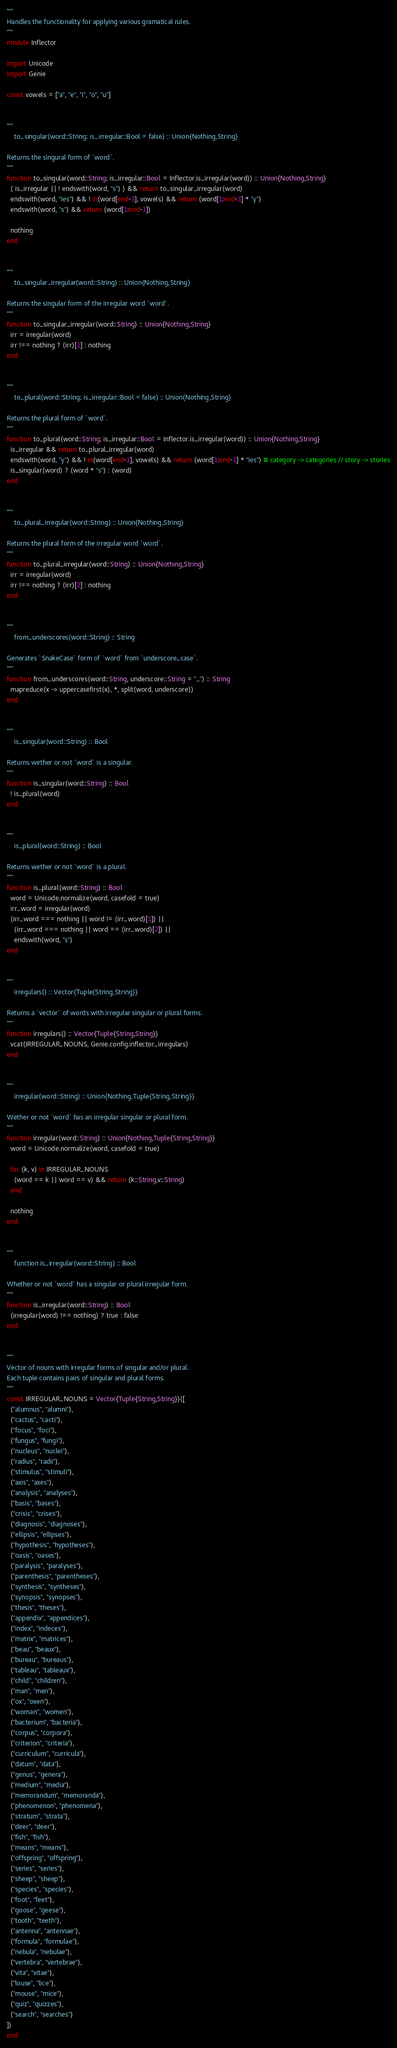<code> <loc_0><loc_0><loc_500><loc_500><_Julia_>"""
Handles the functionality for applying various gramatical rules.
"""
module Inflector

import Unicode
import Genie

const vowels = ["a", "e", "i", "o", "u"]


"""
    to_singular(word::String; is_irregular::Bool = false) :: Union{Nothing,String}

Returns the singural form of `word`.
"""
function to_singular(word::String; is_irregular::Bool = Inflector.is_irregular(word)) :: Union{Nothing,String}
  ( is_irregular || ! endswith(word, "s") ) && return to_singular_irregular(word)
  endswith(word, "ies") && ! in(word[end-3], vowels) && return (word[1:end-3] * "y")
  endswith(word, "s") && return (word[1:end-1])

  nothing
end


"""
    to_singular_irregular(word::String) :: Union{Nothing,String}

Returns the singular form of the irregular word `word`.
"""
function to_singular_irregular(word::String) :: Union{Nothing,String}
  irr = irregular(word)
  irr !== nothing ? (irr)[1] : nothing
end


"""
    to_plural(word::String; is_irregular::Bool = false) :: Union{Nothing,String}

Returns the plural form of `word`.
"""
function to_plural(word::String; is_irregular::Bool = Inflector.is_irregular(word)) :: Union{Nothing,String}
  is_irregular && return to_plural_irregular(word)
  endswith(word, "y") && ! in(word[end-1], vowels) && return (word[1:end-1] * "ies") # category -> categories // story -> stories
  is_singular(word) ? (word * "s") : (word)
end


"""
    to_plural_irregular(word::String) :: Union{Nothing,String}

Returns the plural form of the irregular word `word`.
"""
function to_plural_irregular(word::String) :: Union{Nothing,String}
  irr = irregular(word)
  irr !== nothing ? (irr)[2] : nothing
end


"""
    from_underscores(word::String) :: String

Generates `SnakeCase` form of `word` from `underscore_case`.
"""
function from_underscores(word::String, underscore::String = "_") :: String
  mapreduce(x -> uppercasefirst(x), *, split(word, underscore))
end


"""
    is_singular(word::String) :: Bool

Returns wether or not `word` is a singular.
"""
function is_singular(word::String) :: Bool
  ! is_plural(word)
end


"""
    is_plural(word::String) :: Bool

Returns wether or not `word` is a plural.
"""
function is_plural(word::String) :: Bool
  word = Unicode.normalize(word, casefold = true)
  irr_word = irregular(word)
  (irr_word === nothing || word != (irr_word)[1]) ||
    (irr_word === nothing || word == (irr_word)[2]) ||
    endswith(word, "s")
end


"""
    irregulars() :: Vector{Tuple{String,String}}

Returns a `vector` of words with irregular singular or plural forms.
"""
function irregulars() :: Vector{Tuple{String,String}}
  vcat(IRREGULAR_NOUNS, Genie.config.inflector_irregulars)
end


"""
    irregular(word::String) :: Union{Nothing,Tuple{String,String}}

Wether or not `word` has an irregular singular or plural form.
"""
function irregular(word::String) :: Union{Nothing,Tuple{String,String}}
  word = Unicode.normalize(word, casefold = true)

  for (k, v) in IRREGULAR_NOUNS
    (word == k || word == v) && return (k::String,v::String)
  end

  nothing
end


"""
    function is_irregular(word::String) :: Bool

Whether or not `word` has a singular or plural irregular form.
"""
function is_irregular(word::String) :: Bool
  (irregular(word) !== nothing) ? true : false
end


"""
Vector of nouns with irregular forms of singular and/or plural.
Each tuple contains pairs of singular and plural forms.
"""
const IRREGULAR_NOUNS = Vector{Tuple{String,String}}([
  ("alumnus", "alumni"),
  ("cactus", "cacti"),
  ("focus", "foci"),
  ("fungus", "fungi"),
  ("nucleus", "nuclei"),
  ("radius", "radii"),
  ("stimulus", "stimuli"),
  ("axis", "axes"),
  ("analysis", "analyses"),
  ("basis", "bases"),
  ("crisis", "crises"),
  ("diagnosis", "diagnoses"),
  ("ellipsis", "ellipses"),
  ("hypothesis", "hypotheses"),
  ("oasis", "oases"),
  ("paralysis", "paralyses"),
  ("parenthesis", "parentheses"),
  ("synthesis", "syntheses"),
  ("synopsis", "synopses"),
  ("thesis", "theses"),
  ("appendix", "appendices"),
  ("index", "indeces"),
  ("matrix", "matrices"),
  ("beau", "beaux"),
  ("bureau", "bureaus"),
  ("tableau", "tableaux"),
  ("child", "children"),
  ("man", "men"),
  ("ox", "oxen"),
  ("woman", "women"),
  ("bacterium", "bacteria"),
  ("corpus", "corpora"),
  ("criterion", "criteria"),
  ("curriculum", "curricula"),
  ("datum", "data"),
  ("genus", "genera"),
  ("medium", "media"),
  ("memorandum", "memoranda"),
  ("phenomenon", "phenomena"),
  ("stratum", "strata"),
  ("deer", "deer"),
  ("fish", "fish"),
  ("means", "means"),
  ("offspring", "offspring"),
  ("series", "series"),
  ("sheep", "sheep"),
  ("species", "species"),
  ("foot", "feet"),
  ("goose", "geese"),
  ("tooth", "teeth"),
  ("antenna", "antennae"),
  ("formula", "formulae"),
  ("nebula", "nebulae"),
  ("vertebra", "vertebrae"),
  ("vita", "vitae"),
  ("louse", "lice"),
  ("mouse", "mice"),
  ("quiz", "quizzes"),
  ("search", "searches")
])
end
</code> 